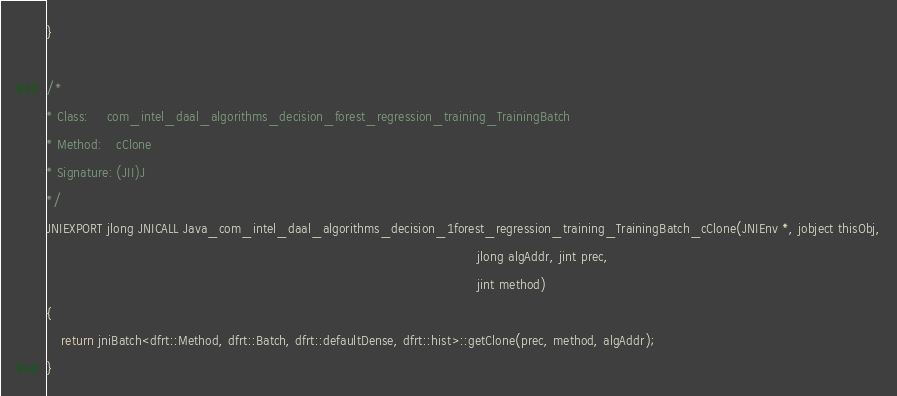Convert code to text. <code><loc_0><loc_0><loc_500><loc_500><_C++_>}

/*
* Class:     com_intel_daal_algorithms_decision_forest_regression_training_TrainingBatch
* Method:    cClone
* Signature: (JII)J
*/
JNIEXPORT jlong JNICALL Java_com_intel_daal_algorithms_decision_1forest_regression_training_TrainingBatch_cClone(JNIEnv *, jobject thisObj,
                                                                                                                 jlong algAddr, jint prec,
                                                                                                                 jint method)
{
    return jniBatch<dfrt::Method, dfrt::Batch, dfrt::defaultDense, dfrt::hist>::getClone(prec, method, algAddr);
}
</code> 